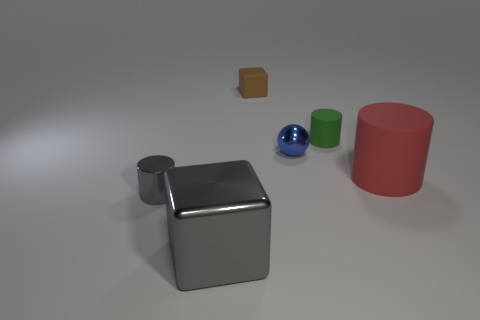What could be the purpose of creating this image? This image might have been created for multiple purposes. It could serve as a test for rendering techniques in digital graphics, demonstrating how different materials and shapes interact with a light source. Alternatively, it could be used in an educational context to teach about geometry, colors, or material properties. Its clear and simple layout also makes it suitable for cognitive tests evaluating shape recognition or spatial reasoning. 